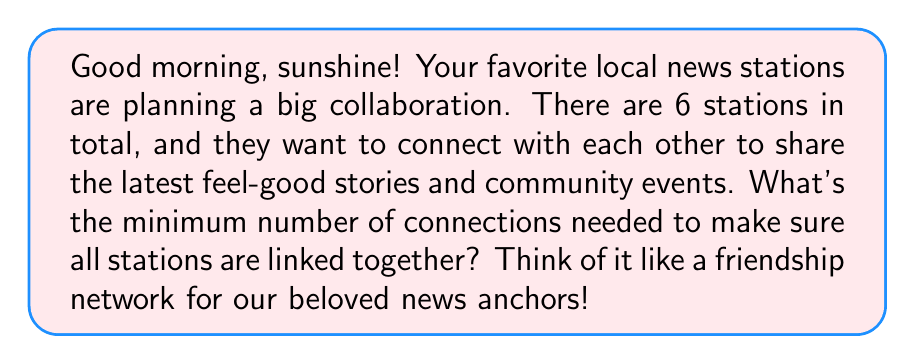Solve this math problem. Let's break this down step-by-step, just like how we plan our morning routine!

1) This problem is actually a classic example from graph theory called the "minimum spanning tree" problem. Don't worry about the fancy term - it's just a way to connect all points (our news stations) with the least number of lines (connections).

2) The formula for the minimum number of connections in a network is:

   $$ \text{Minimum Connections} = n - 1 $$

   Where $n$ is the number of nodes (in our case, news stations).

3) We have 6 news stations, so let's plug that into our formula:

   $$ \text{Minimum Connections} = 6 - 1 = 5 $$

4) To visualize this, imagine our news anchors standing in a circle. We can connect them like this:

   [asy]
   unitsize(1cm);
   for(int i=0; i<6; ++i) {
     dot((2*cos(2pi*i/6), 2*sin(2pi*i/6)));
     if(i < 5) {
       draw((2*cos(2pi*i/6), 2*sin(2pi*i/6))--(2*cos(2pi*(i+1)/6), 2*sin(2pi*(i+1)/6)));
     }
   }
   [/asy]

   See how we used just 5 connections to link all 6 stations?

5) This way, every station can share news with every other station, either directly or through other stations, using the least number of connections possible.

So, just like how we efficiently plan our morning to catch all our favorite segments, we've found the most efficient way to connect our local news stations!
Answer: The minimum number of connections needed to link all 6 local news stations is 5. 